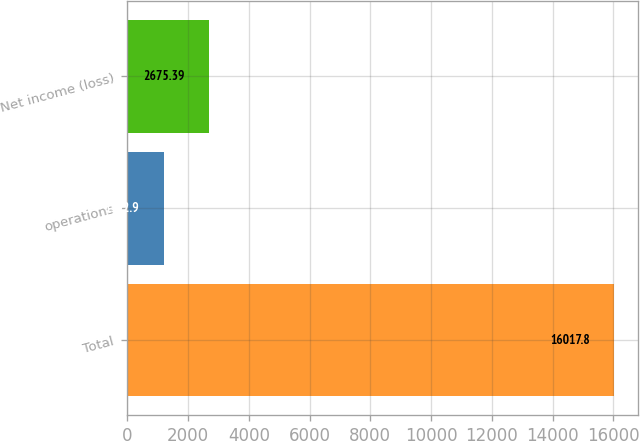Convert chart. <chart><loc_0><loc_0><loc_500><loc_500><bar_chart><fcel>Total<fcel>operations<fcel>Net income (loss)<nl><fcel>16017.8<fcel>1192.9<fcel>2675.39<nl></chart> 